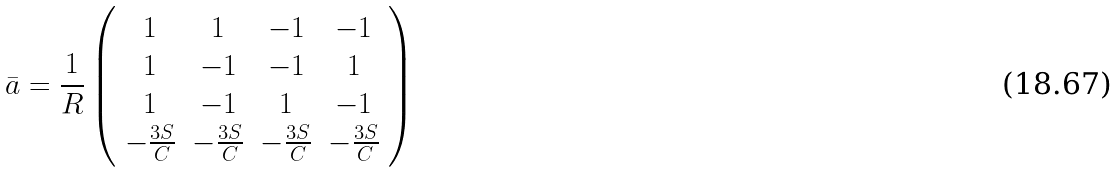<formula> <loc_0><loc_0><loc_500><loc_500>\bar { a } = \frac { 1 } { R } \left ( \begin{array} { c c c c } 1 & 1 & - 1 & - 1 \\ 1 & - 1 & - 1 & 1 \\ 1 & - 1 & 1 & - 1 \\ - \frac { 3 S } { C } & - \frac { 3 S } { C } & - \frac { 3 S } { C } & - \frac { 3 S } { C } \end{array} \right )</formula> 